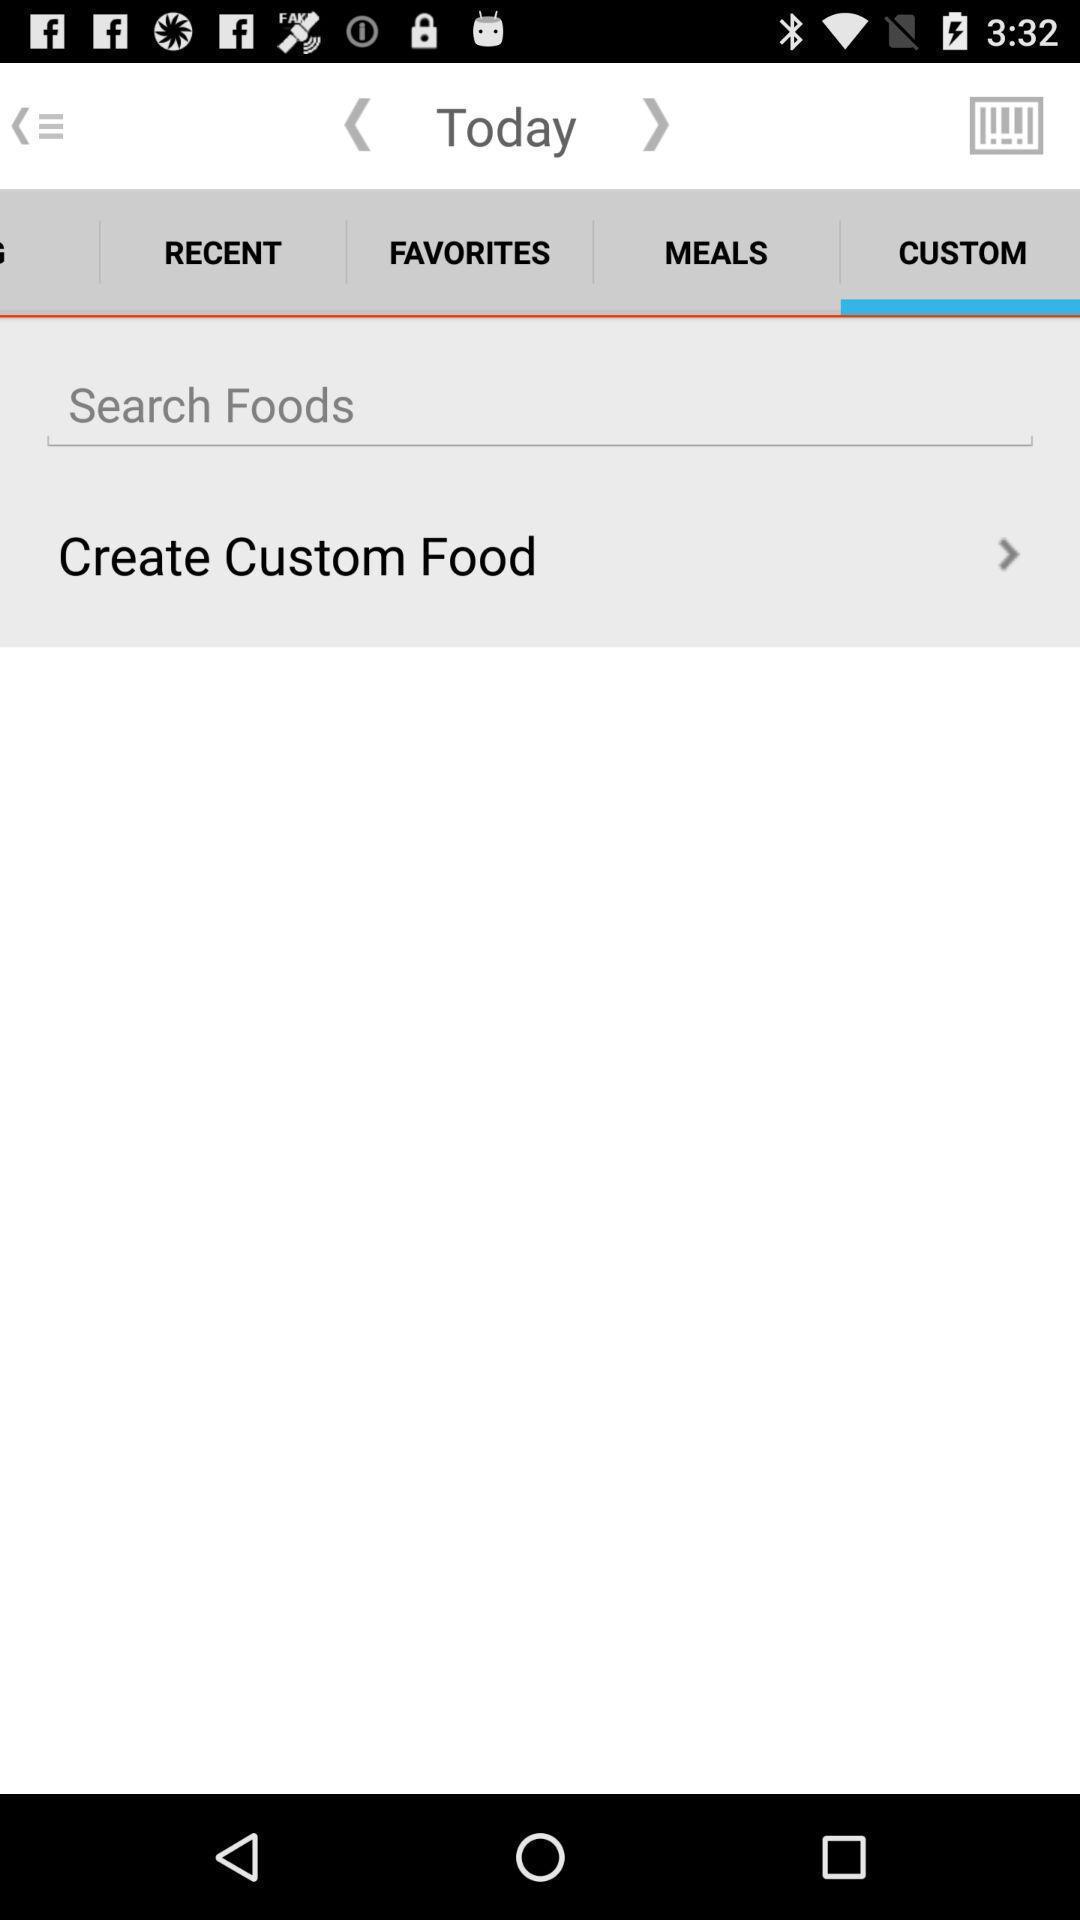Tell me about the visual elements in this screen capture. Search page of a food app. 